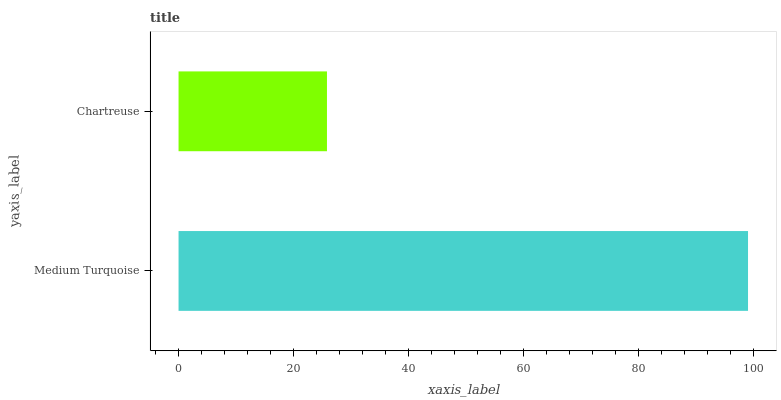Is Chartreuse the minimum?
Answer yes or no. Yes. Is Medium Turquoise the maximum?
Answer yes or no. Yes. Is Chartreuse the maximum?
Answer yes or no. No. Is Medium Turquoise greater than Chartreuse?
Answer yes or no. Yes. Is Chartreuse less than Medium Turquoise?
Answer yes or no. Yes. Is Chartreuse greater than Medium Turquoise?
Answer yes or no. No. Is Medium Turquoise less than Chartreuse?
Answer yes or no. No. Is Medium Turquoise the high median?
Answer yes or no. Yes. Is Chartreuse the low median?
Answer yes or no. Yes. Is Chartreuse the high median?
Answer yes or no. No. Is Medium Turquoise the low median?
Answer yes or no. No. 